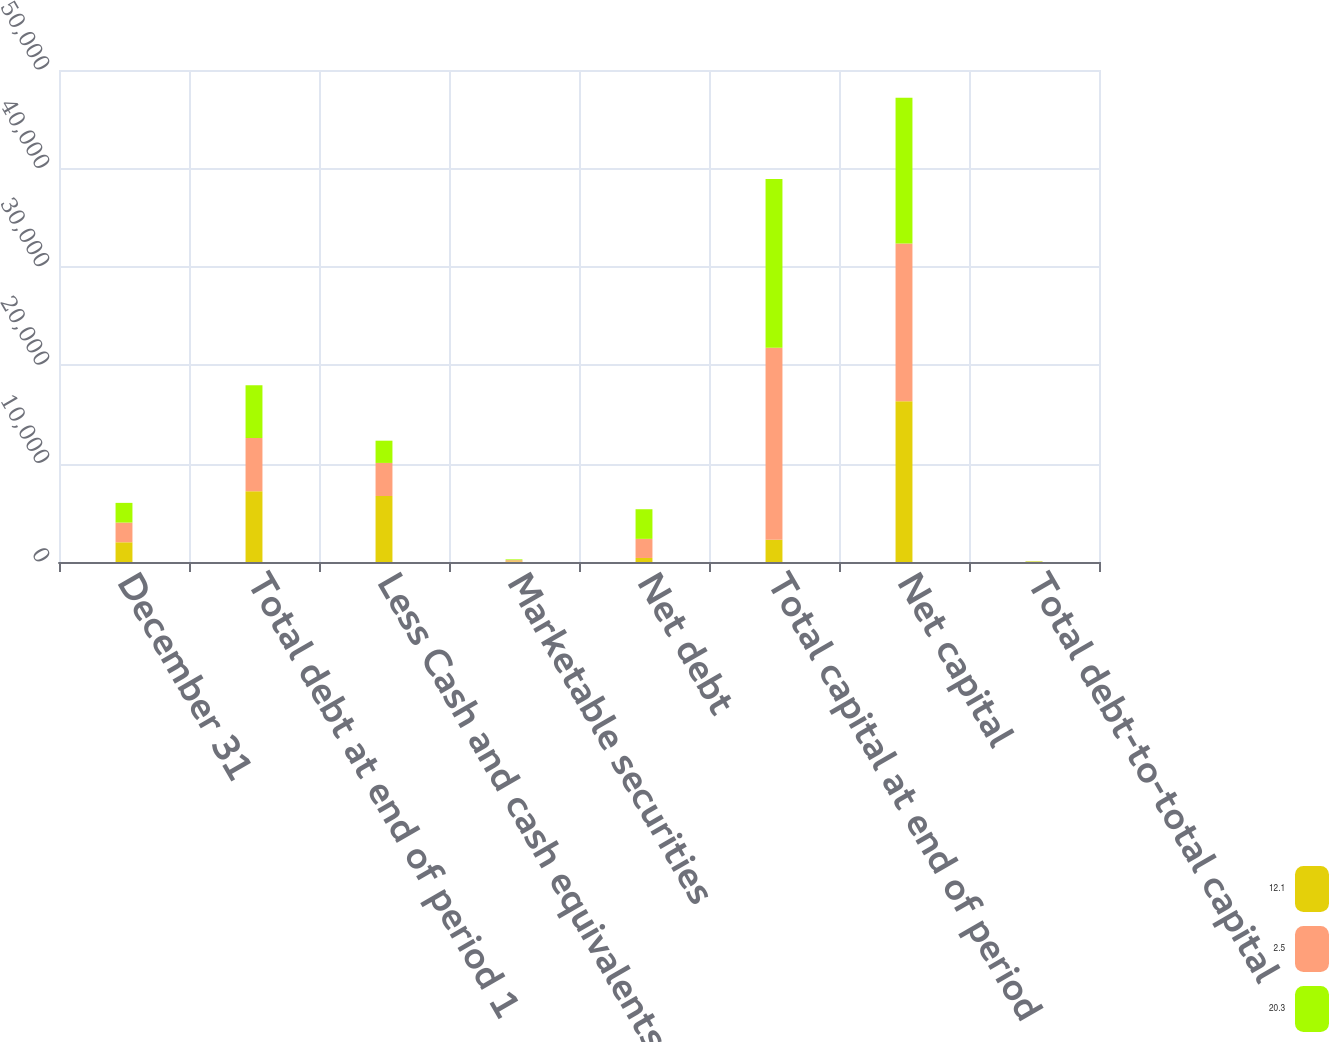<chart> <loc_0><loc_0><loc_500><loc_500><stacked_bar_chart><ecel><fcel>December 31<fcel>Total debt at end of period 1<fcel>Less Cash and cash equivalents<fcel>Marketable securities<fcel>Net debt<fcel>Total capital at end of period<fcel>Net capital<fcel>Total debt-to-total capital<nl><fcel>12.1<fcel>2004<fcel>7178<fcel>6707<fcel>61<fcel>410<fcel>2260<fcel>16345<fcel>31.1<nl><fcel>2.5<fcel>2003<fcel>5423<fcel>3362<fcel>120<fcel>1941<fcel>19513<fcel>16031<fcel>27.8<nl><fcel>20.3<fcel>2002<fcel>5356<fcel>2260<fcel>85<fcel>3011<fcel>17156<fcel>14811<fcel>31.2<nl></chart> 